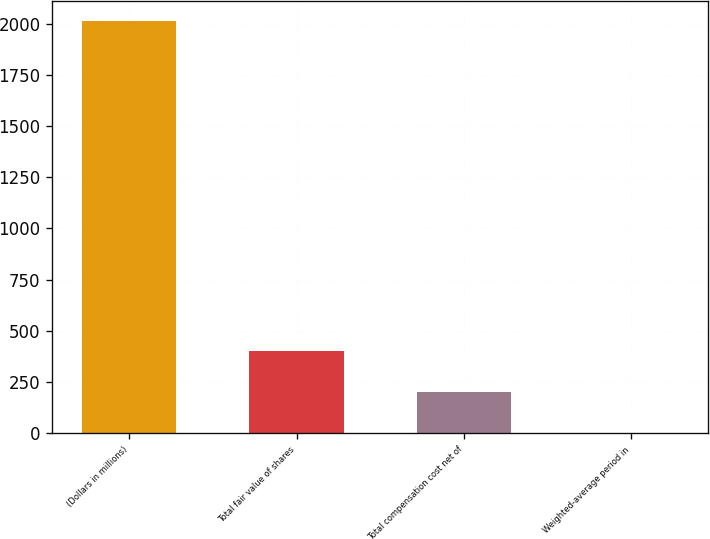Convert chart. <chart><loc_0><loc_0><loc_500><loc_500><bar_chart><fcel>(Dollars in millions)<fcel>Total fair value of shares<fcel>Total compensation cost net of<fcel>Weighted-average period in<nl><fcel>2010<fcel>403.6<fcel>202.8<fcel>2<nl></chart> 